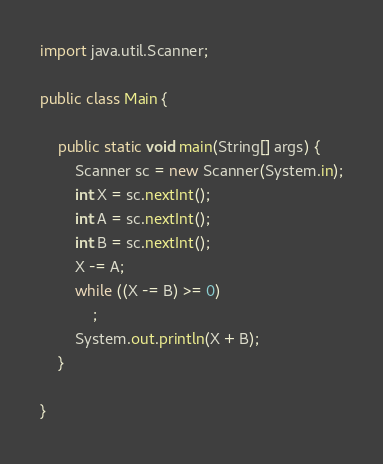Convert code to text. <code><loc_0><loc_0><loc_500><loc_500><_Java_>import java.util.Scanner;

public class Main {

	public static void main(String[] args) {
		Scanner sc = new Scanner(System.in);
		int X = sc.nextInt();
		int A = sc.nextInt();
		int B = sc.nextInt();
		X -= A;
		while ((X -= B) >= 0)
			;
		System.out.println(X + B);
	}

}
</code> 